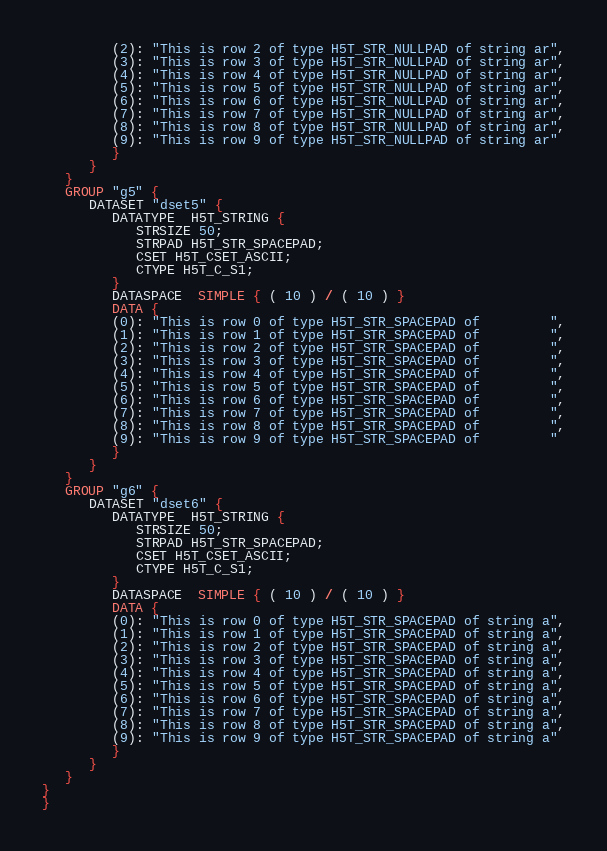Convert code to text. <code><loc_0><loc_0><loc_500><loc_500><_SQL_>         (2): "This is row 2 of type H5T_STR_NULLPAD of string ar",
         (3): "This is row 3 of type H5T_STR_NULLPAD of string ar",
         (4): "This is row 4 of type H5T_STR_NULLPAD of string ar",
         (5): "This is row 5 of type H5T_STR_NULLPAD of string ar",
         (6): "This is row 6 of type H5T_STR_NULLPAD of string ar",
         (7): "This is row 7 of type H5T_STR_NULLPAD of string ar",
         (8): "This is row 8 of type H5T_STR_NULLPAD of string ar",
         (9): "This is row 9 of type H5T_STR_NULLPAD of string ar"
         }
      }
   }
   GROUP "g5" {
      DATASET "dset5" {
         DATATYPE  H5T_STRING {
            STRSIZE 50;
            STRPAD H5T_STR_SPACEPAD;
            CSET H5T_CSET_ASCII;
            CTYPE H5T_C_S1;
         }
         DATASPACE  SIMPLE { ( 10 ) / ( 10 ) }
         DATA {
         (0): "This is row 0 of type H5T_STR_SPACEPAD of         ",
         (1): "This is row 1 of type H5T_STR_SPACEPAD of         ",
         (2): "This is row 2 of type H5T_STR_SPACEPAD of         ",
         (3): "This is row 3 of type H5T_STR_SPACEPAD of         ",
         (4): "This is row 4 of type H5T_STR_SPACEPAD of         ",
         (5): "This is row 5 of type H5T_STR_SPACEPAD of         ",
         (6): "This is row 6 of type H5T_STR_SPACEPAD of         ",
         (7): "This is row 7 of type H5T_STR_SPACEPAD of         ",
         (8): "This is row 8 of type H5T_STR_SPACEPAD of         ",
         (9): "This is row 9 of type H5T_STR_SPACEPAD of         "
         }
      }
   }
   GROUP "g6" {
      DATASET "dset6" {
         DATATYPE  H5T_STRING {
            STRSIZE 50;
            STRPAD H5T_STR_SPACEPAD;
            CSET H5T_CSET_ASCII;
            CTYPE H5T_C_S1;
         }
         DATASPACE  SIMPLE { ( 10 ) / ( 10 ) }
         DATA {
         (0): "This is row 0 of type H5T_STR_SPACEPAD of string a",
         (1): "This is row 1 of type H5T_STR_SPACEPAD of string a",
         (2): "This is row 2 of type H5T_STR_SPACEPAD of string a",
         (3): "This is row 3 of type H5T_STR_SPACEPAD of string a",
         (4): "This is row 4 of type H5T_STR_SPACEPAD of string a",
         (5): "This is row 5 of type H5T_STR_SPACEPAD of string a",
         (6): "This is row 6 of type H5T_STR_SPACEPAD of string a",
         (7): "This is row 7 of type H5T_STR_SPACEPAD of string a",
         (8): "This is row 8 of type H5T_STR_SPACEPAD of string a",
         (9): "This is row 9 of type H5T_STR_SPACEPAD of string a"
         }
      }
   }
}
}
</code> 